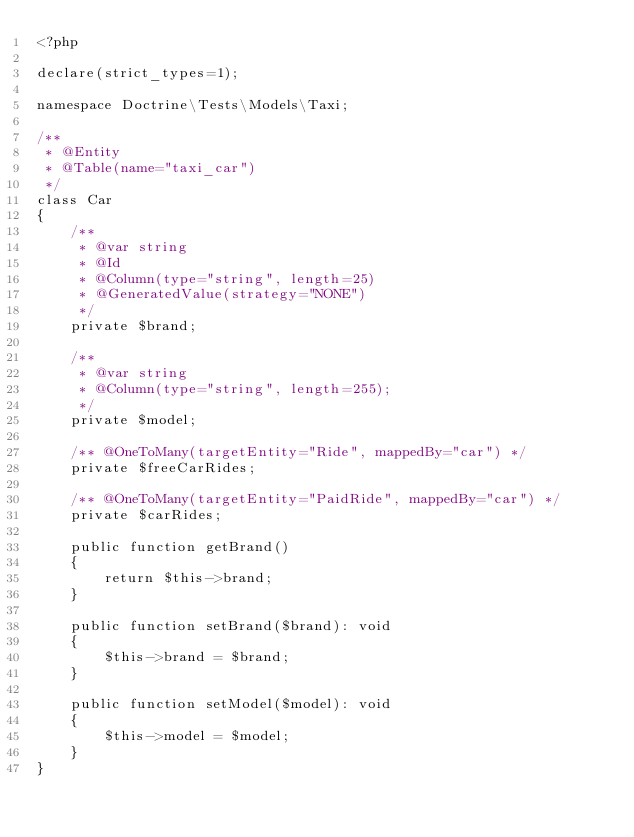Convert code to text. <code><loc_0><loc_0><loc_500><loc_500><_PHP_><?php

declare(strict_types=1);

namespace Doctrine\Tests\Models\Taxi;

/**
 * @Entity
 * @Table(name="taxi_car")
 */
class Car
{
    /**
     * @var string
     * @Id
     * @Column(type="string", length=25)
     * @GeneratedValue(strategy="NONE")
     */
    private $brand;

    /**
     * @var string
     * @Column(type="string", length=255);
     */
    private $model;

    /** @OneToMany(targetEntity="Ride", mappedBy="car") */
    private $freeCarRides;

    /** @OneToMany(targetEntity="PaidRide", mappedBy="car") */
    private $carRides;

    public function getBrand()
    {
        return $this->brand;
    }

    public function setBrand($brand): void
    {
        $this->brand = $brand;
    }

    public function setModel($model): void
    {
        $this->model = $model;
    }
}
</code> 